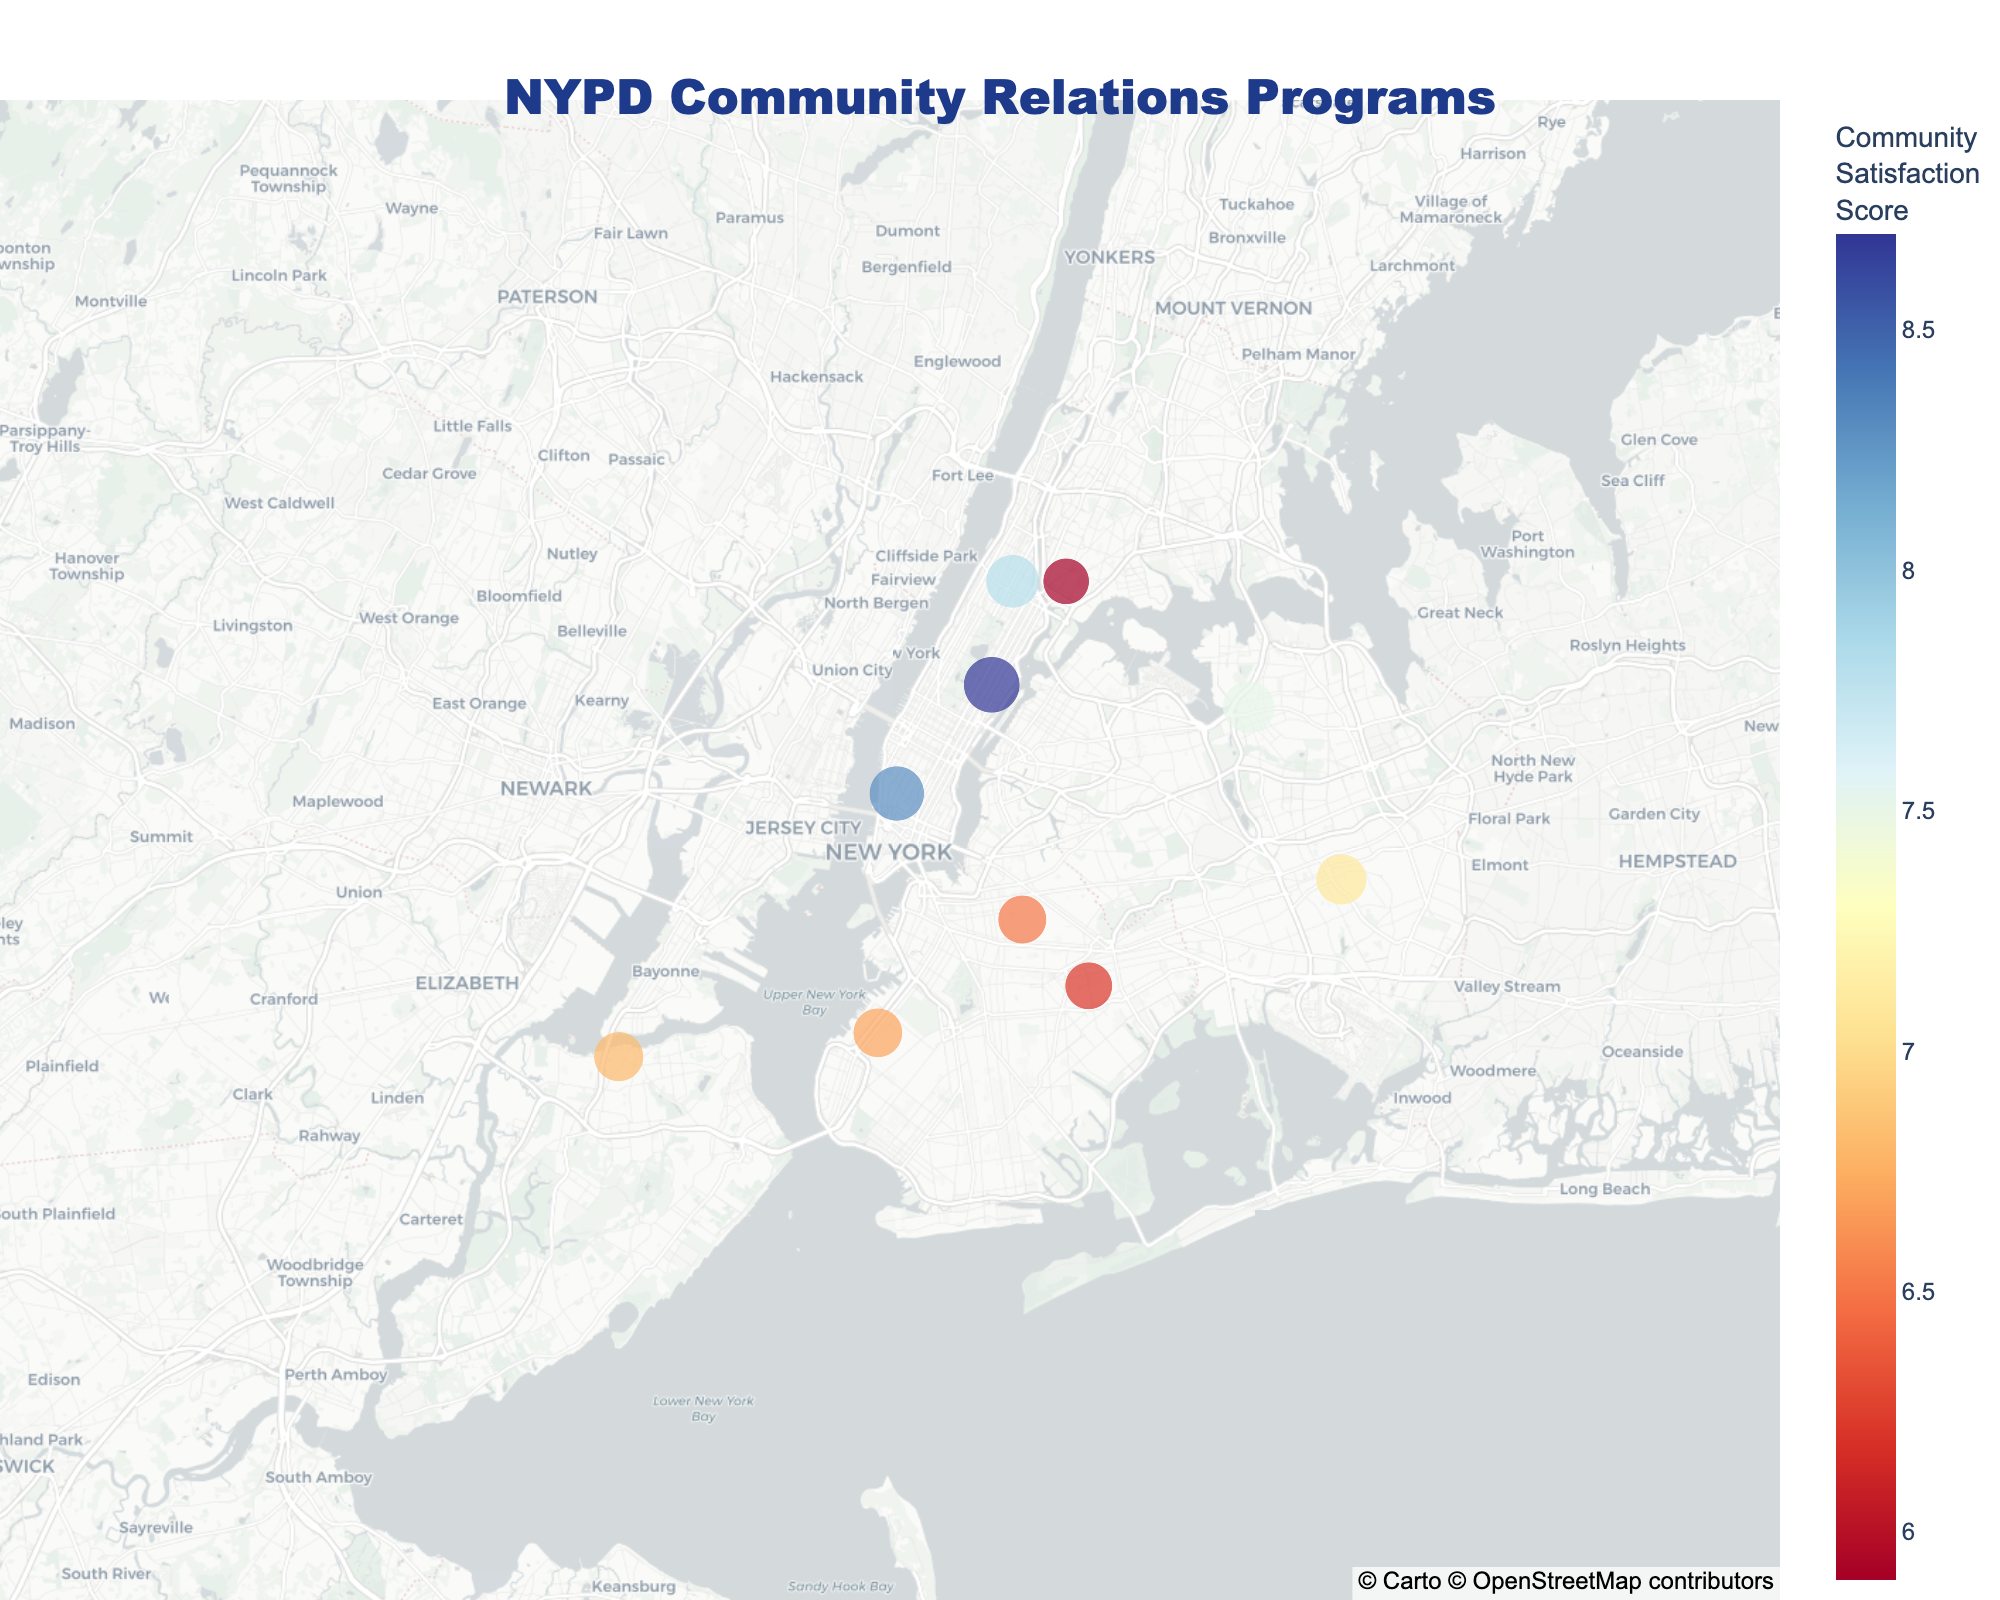How many neighborhoods are represented in the figure? Count each unique neighborhood shown on the map. There are ten data points visible, each representing a unique neighborhood.
Answer: 10 Which neighborhood has the program with the highest community satisfaction score? Identify the highest community satisfaction score on the color scale, then locate the corresponding program and neighborhood. The Upper East Side with "Coffee with a Cop" has the highest score of 8.7.
Answer: Upper East Side What type of program is implemented in Harlem, and what is its community satisfaction score? Look for the marker at Harlem's location on the map, then check the hover data for the program and its score. Harlem has "Block Parties" with a satisfaction score of 7.8.
Answer: Block Parties, 7.8 Based on the figure, which neighborhoods have satisfaction scores greater than 7, and what are their respective programs? Identify all markers with colors indicating scores above 7, refer to the hover data to list these neighborhoods and programs: Upper East Side (Coffee with a Cop), Flushing (Community Outreach Van), Harlem (Block Parties), Greenwich Village (LGBTQ+ Liaison Initiative), Jamaica (Senior Safety Workshops).
Answer: Upper East Side: Coffee with a Cop, Flushing: Community Outreach Van, Harlem: Block Parties, Greenwich Village: LGBTQ+ Liaison Initiative, Jamaica: Senior Safety Workshops Which program is displayed in Sunset Park, and how does its community satisfaction score compare to that of Staten Island North Shore? Locate the markers for Sunset Park and Staten Island North Shore, then compare their scores. Sunset Park has the "Immigrant Outreach Program" with a score of 6.7, whereas Staten Island North Shore has the "Citizens Police Academy" with a score of 6.8. 6.7 (Sunset Park) is less than 6.8 (Staten Island North Shore).
Answer: Immigrant Outreach Program, 6.7 < 6.8 Which neighborhood has the lowest community satisfaction score, and what program is it associated with? Find the marker with the lowest score on the color scale and check the hover data for this neighborhood and program. The South Bronx has the lowest score of 5.9 with "Neighborhood Watch".
Answer: South Bronx, Neighborhood Watch What is the average community satisfaction score across all the programs displayed? Add all the community satisfaction scores together and divide by the number of neighborhoods: (6.2 + 8.7 + 5.9 + 7.5 + 7.8 + 6.8 + 6.5 + 8.3 + 7.1 + 6.7) / 10 = 7.15
Answer: 7.15 What is the program implemented in Brownsville, and what exact location (latitude and longitude) is it associated with? Locate Brownsville on the map and check the hover data for the specific coordinates and program name. Brownsville has the "Youth Police Academy" program with coordinates (40.6628, -73.9095).
Answer: Youth Police Academy, (40.6628, -73.9095) How much higher is the community satisfaction score of Flushing compared to that of Sunset Park? Subtract the score of Sunset Park from the score of Flushing: 7.5 (Flushing) - 6.7 (Sunset Park) equals 0.8.
Answer: 0.8 